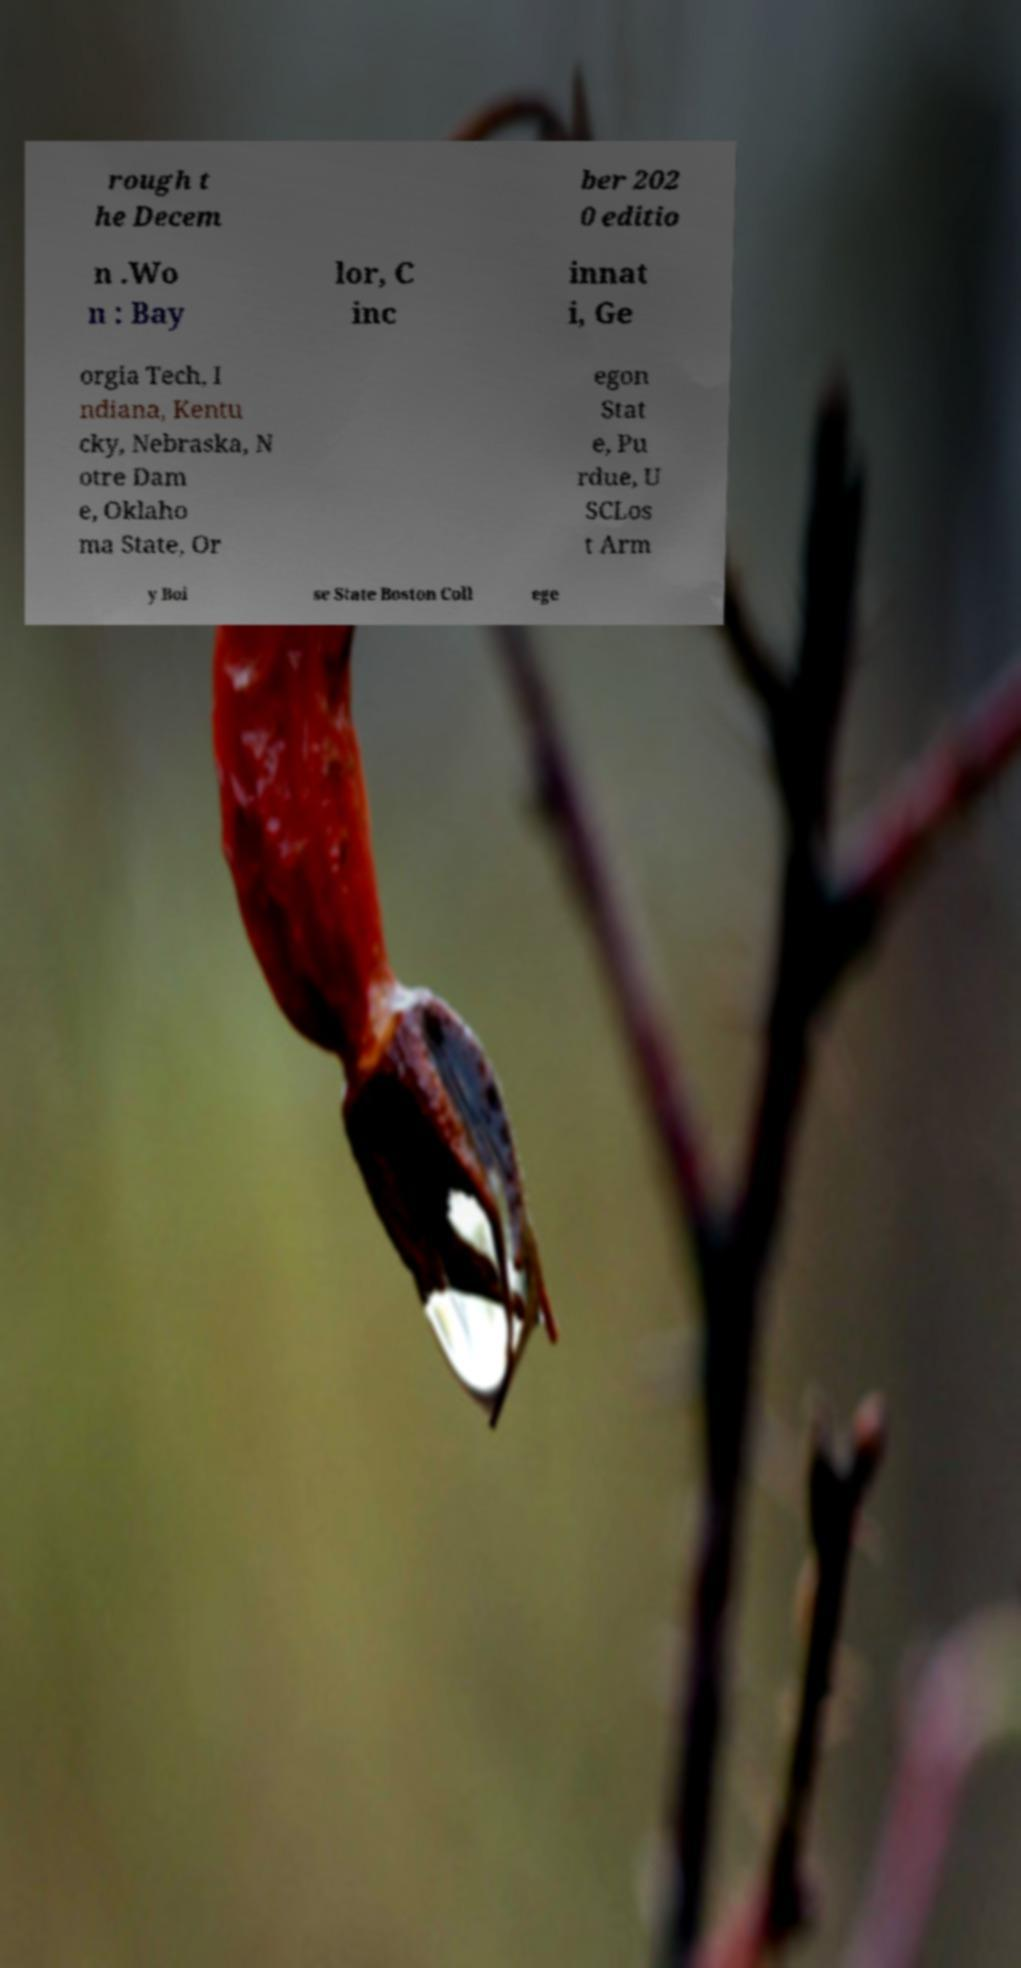Can you accurately transcribe the text from the provided image for me? rough t he Decem ber 202 0 editio n .Wo n : Bay lor, C inc innat i, Ge orgia Tech, I ndiana, Kentu cky, Nebraska, N otre Dam e, Oklaho ma State, Or egon Stat e, Pu rdue, U SCLos t Arm y Boi se State Boston Coll ege 